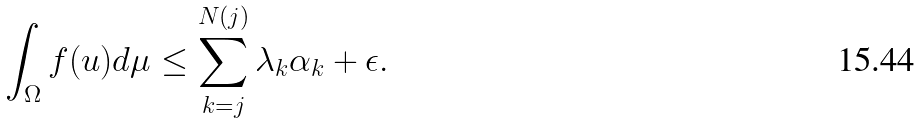Convert formula to latex. <formula><loc_0><loc_0><loc_500><loc_500>\int _ { \Omega } f ( u ) d \mu \leq \sum _ { k = j } ^ { N ( j ) } \lambda _ { k } \alpha _ { k } + \epsilon .</formula> 